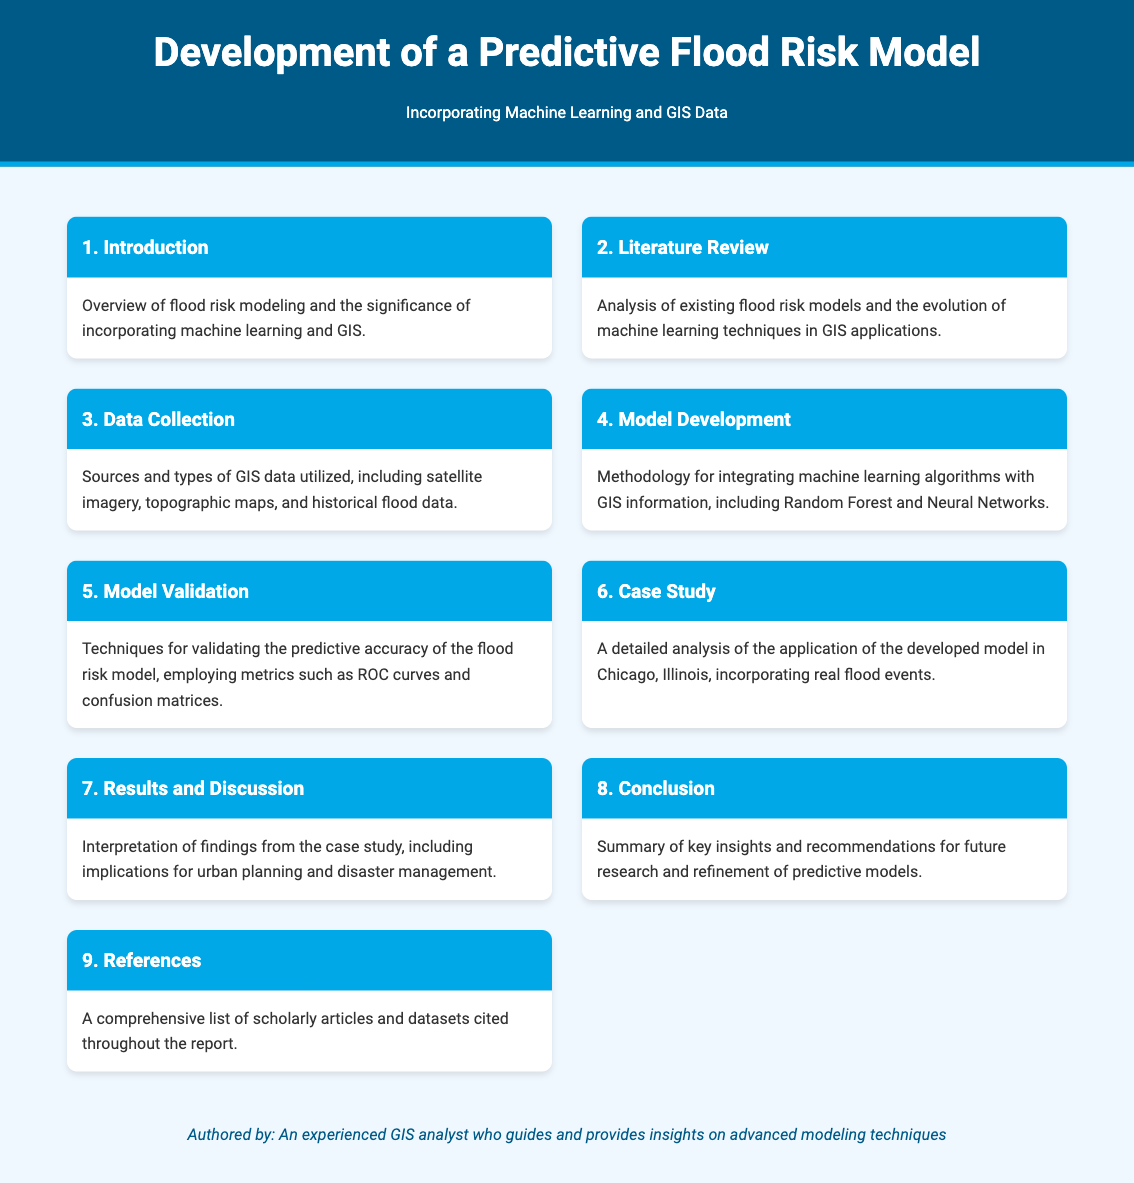What is the title of the report? The title is presented prominently at the top of the document, which specifies the focus of the report.
Answer: Development of a Predictive Flood Risk Model What is the focus of the report? The report focuses on the integration of machine learning and GIS data for effective flood risk modeling.
Answer: Predictive Flood Risk Model incorporating Machine Learning and GIS Data How many sections are in this report? The document menu outlines a total of nine sections detailing various aspects of the flood risk model.
Answer: Nine What methodology is discussed for the model development? The report includes a specific mention of methodologies for integrating algorithms with GIS data, highlighting notable methods.
Answer: Random Forest and Neural Networks What types of data are collected for the model? The section on data collection specifies the diverse sources of GIS data that are employed in the study.
Answer: Satellite imagery, topographic maps, and historical flood data In which city is the case study performed? The detailed case study section provides the name of the city where the developed model has been applied.
Answer: Chicago What metrics are used for model validation? The report identifies particular metrics critical for evaluating the predictive accuracy of the developed flood risk model.
Answer: ROC curves and confusion matrices What is discussed in the results and discussion section? This section interprets the findings of the case study and discusses its implications for related fields.
Answer: Implications for urban planning and disaster management What type of report is this? Given the organization and content, this document serves as a technical report.
Answer: Technical Report 